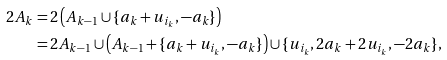<formula> <loc_0><loc_0><loc_500><loc_500>2 A _ { k } & = 2 \left ( A _ { k - 1 } \cup \{ a _ { k } + u _ { i _ { k } } , - a _ { k } \} \right ) \\ & = 2 A _ { k - 1 } \cup \left ( A _ { k - 1 } + \{ a _ { k } + u _ { i _ { k } } , - a _ { k } \} \right ) \cup \{ u _ { i _ { k } } , 2 a _ { k } + 2 u _ { i _ { k } } , - 2 a _ { k } \} ,</formula> 